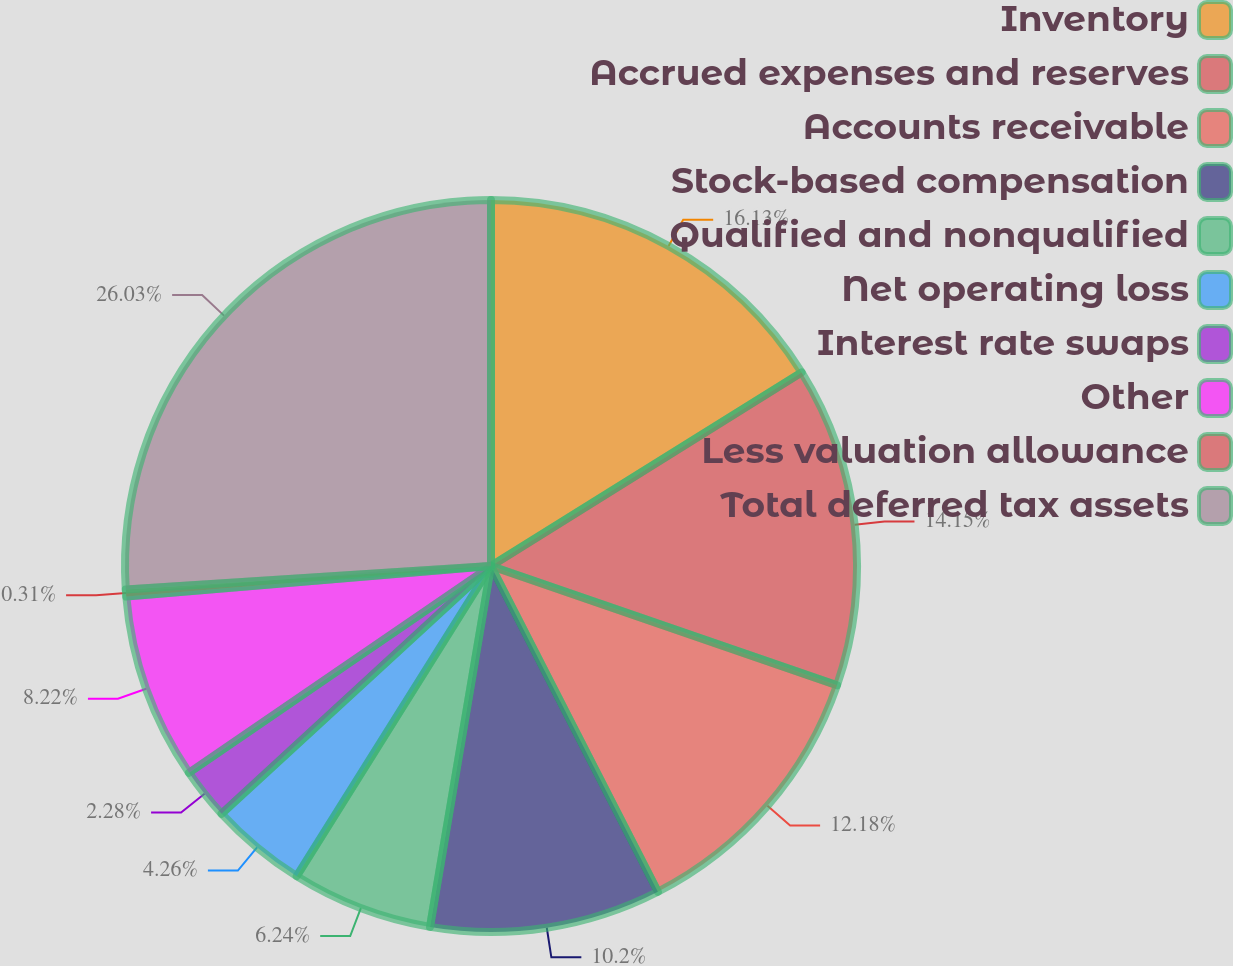<chart> <loc_0><loc_0><loc_500><loc_500><pie_chart><fcel>Inventory<fcel>Accrued expenses and reserves<fcel>Accounts receivable<fcel>Stock-based compensation<fcel>Qualified and nonqualified<fcel>Net operating loss<fcel>Interest rate swaps<fcel>Other<fcel>Less valuation allowance<fcel>Total deferred tax assets<nl><fcel>16.13%<fcel>14.15%<fcel>12.18%<fcel>10.2%<fcel>6.24%<fcel>4.26%<fcel>2.28%<fcel>8.22%<fcel>0.31%<fcel>26.02%<nl></chart> 